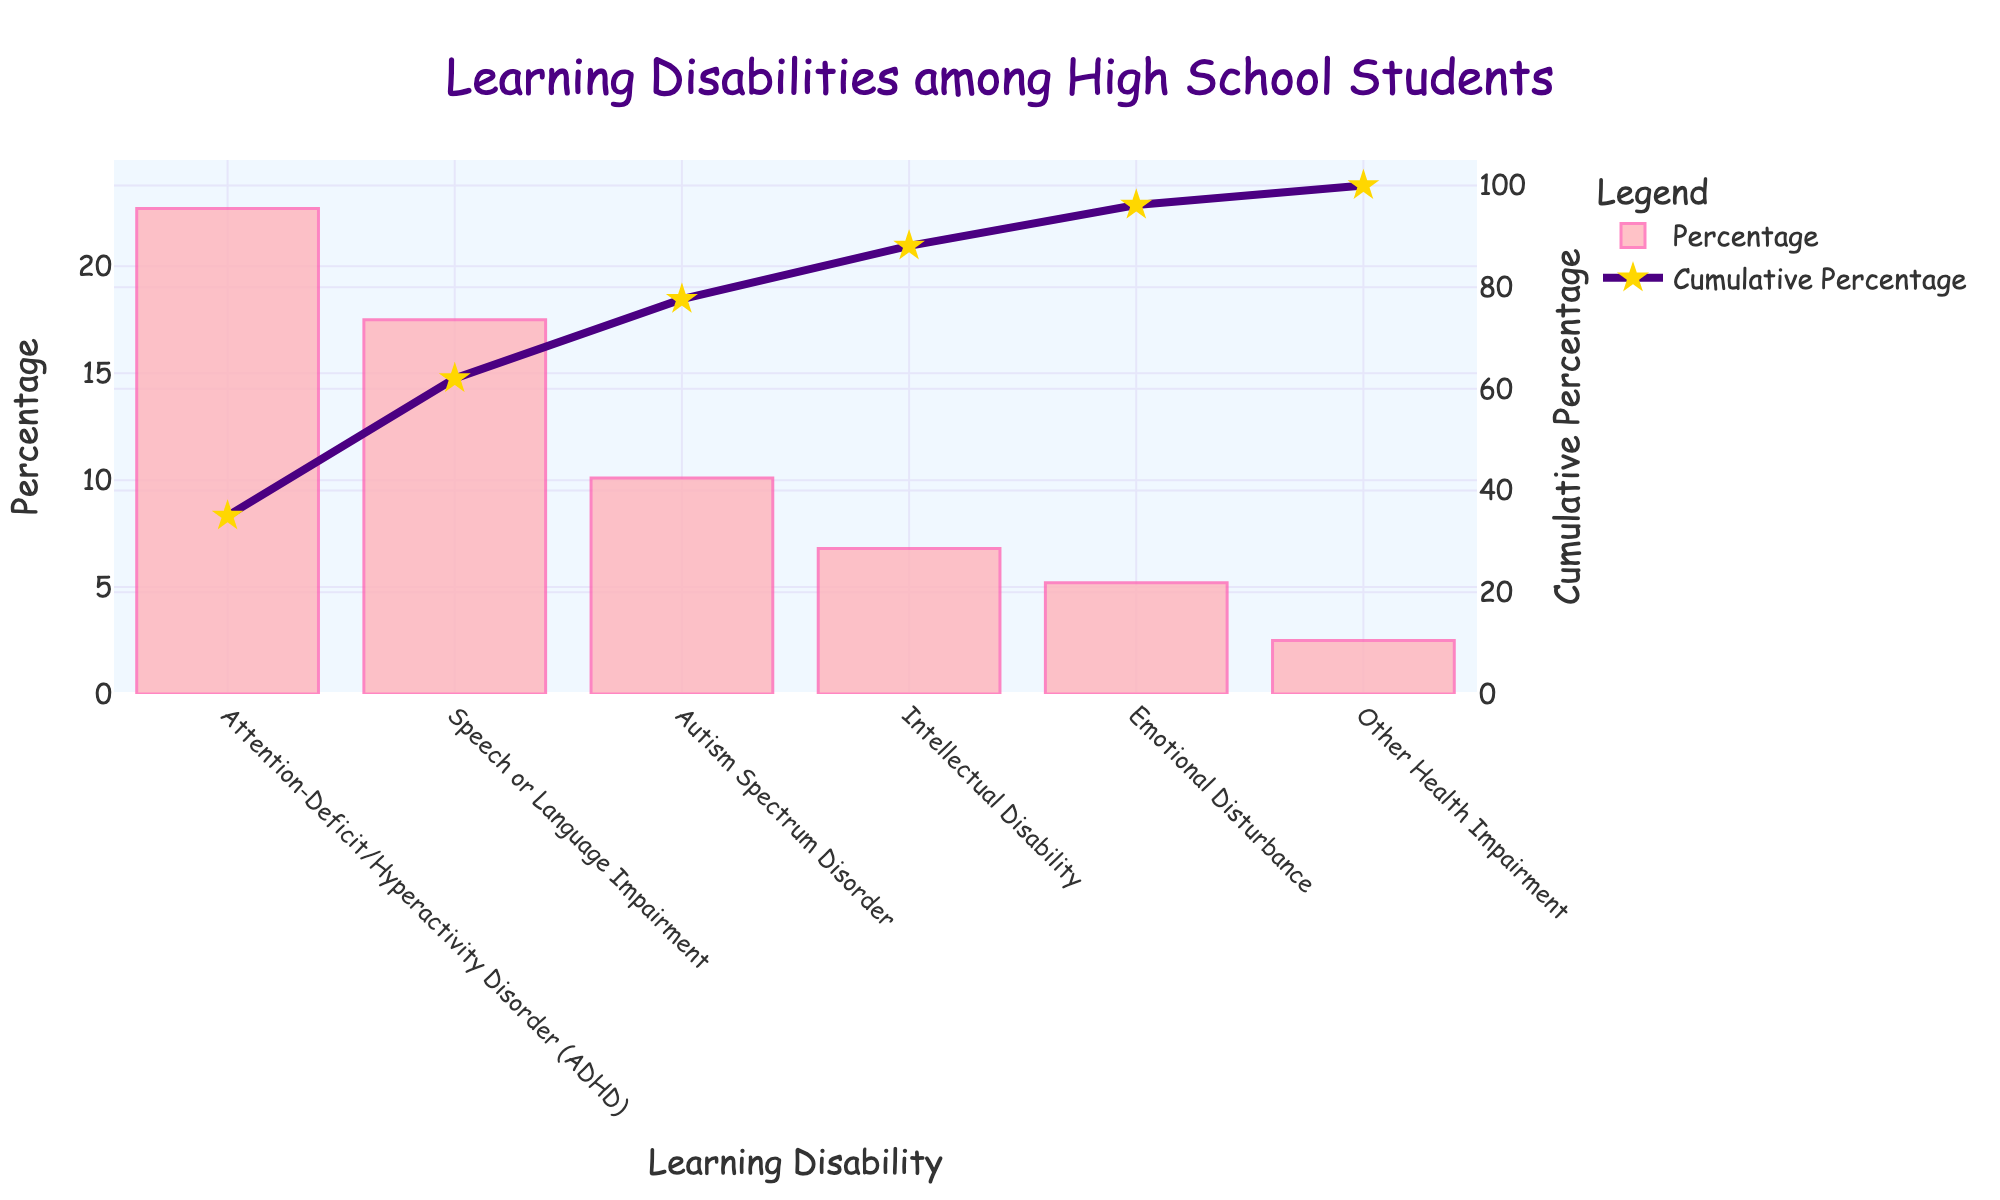What's the most common learning disability among high school students according to the chart? The chart's bars show that Attention-Deficit/Hyperactivity Disorder (ADHD) has the highest percentage.
Answer: Attention-Deficit/Hyperactivity Disorder (ADHD) What is the cumulative percentage of the top two most common learning disabilities? By looking at the line graph, you can see that the cumulative percentage after ADHD and Speech or Language Impairment is around 40.2% (22.7% for ADHD + 17.5% for Speech or Language Impairment).
Answer: 40.2% How much more common is ADHD compared to Emotional Disturbance? The percentage for ADHD is 22.7%, whereas for Emotional Disturbance it's 5.2%. Subtract the smaller percentage from the larger: 22.7 - 5.2 = 17.5%.
Answer: 17.5% Which learning disability has a cumulative percentage closest to 50%? Check the line graph for the point where the cumulative percentage line is closest to 50%. Autism Spectrum Disorder is listed after ADHD and Speech or Language Impairment, bringing the cumulative percentage close to 50%.
Answer: Autism Spectrum Disorder What is the total percentage of high school students with Autism Spectrum Disorder, Intellectual Disability, and Emotional Disturbance combined? Sum the percentages for these three disabilities: Autism Spectrum Disorder (10.1%), Intellectual Disability (6.8%), and Emotional Disturbance (5.2%). So, 10.1 + 6.8 + 5.2 = 22.1%.
Answer: 22.1% What's the cumulative percentage increase from Speech or Language Impairment to Autism Spectrum Disorder in the chart? Speech or Language Impairment has a cumulative percentage of 22.7% + 17.5% and Autism Spectrum Disorder adds an additional 10.1%. To find the increase, look at the cumulative percentage before and after Autism Spectrum Disorder. 50.3% - 40.2% = 10.1%.
Answer: 10.1% How many learning disabilities are listed in the chart? Count the distinct bars for each learning disability in the chart. There are six.
Answer: 6 